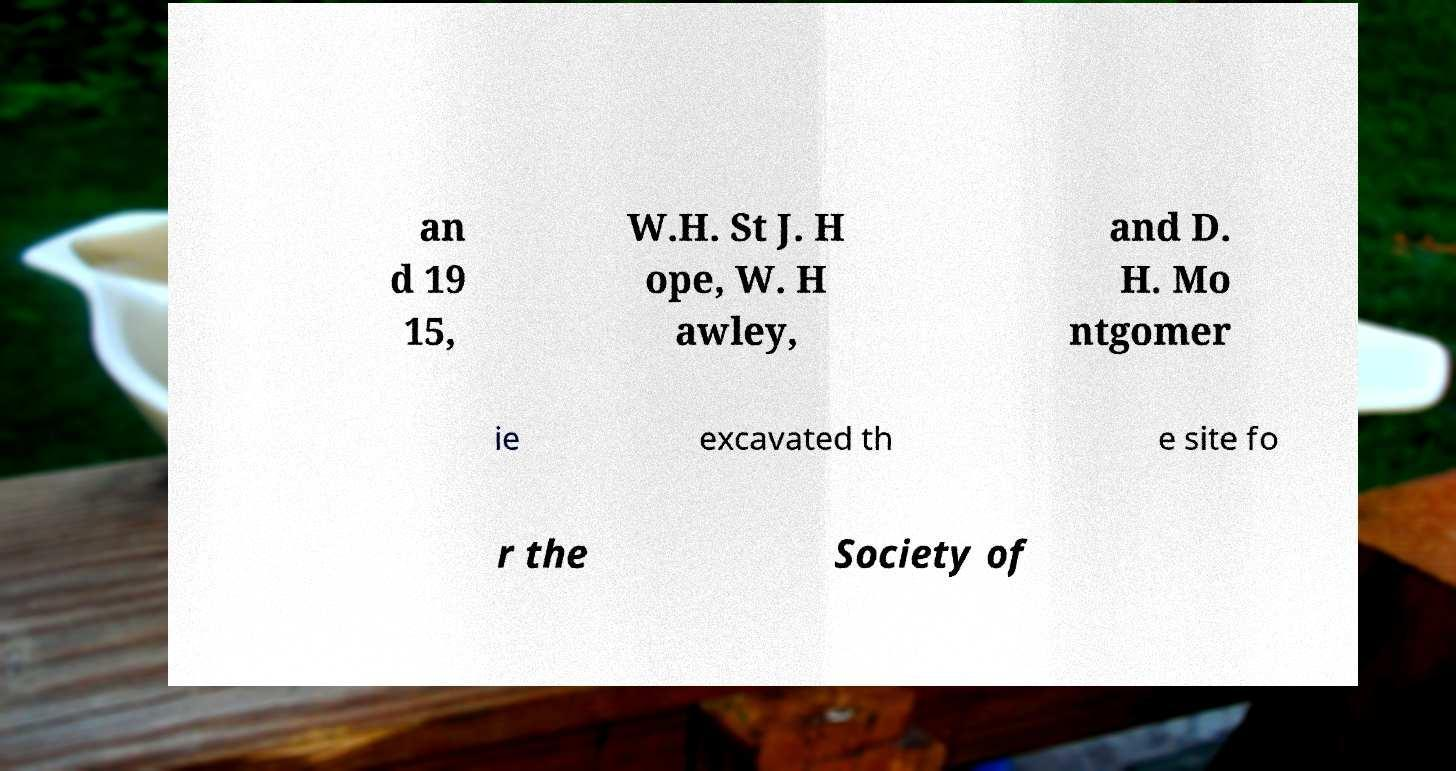There's text embedded in this image that I need extracted. Can you transcribe it verbatim? an d 19 15, W.H. St J. H ope, W. H awley, and D. H. Mo ntgomer ie excavated th e site fo r the Society of 